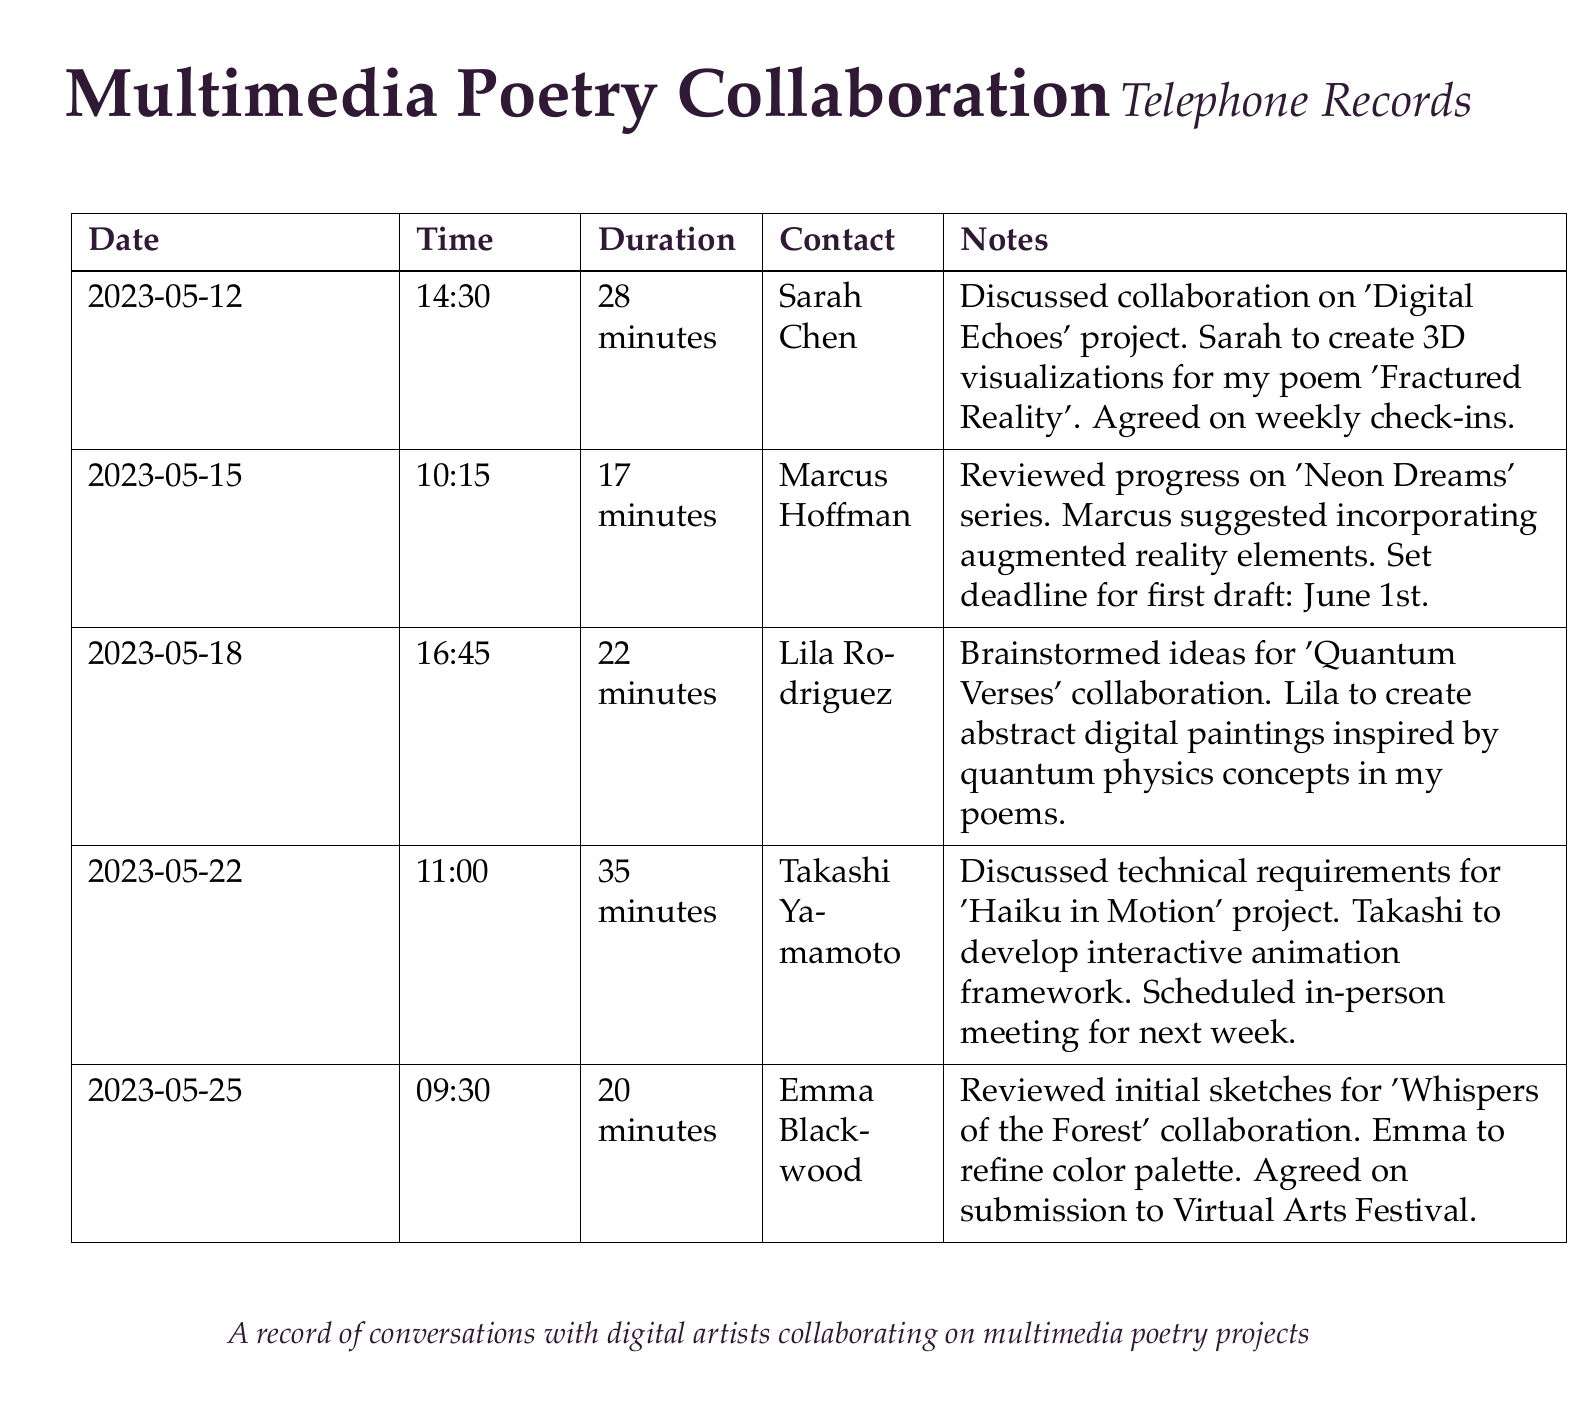What is the date of the first recorded conversation? The first recorded conversation took place on May 12, 2023.
Answer: May 12, 2023 Who is the contact for the 'Digital Echoes' project? The contact for the 'Digital Echoes' project is Sarah Chen.
Answer: Sarah Chen What is the duration of the call with Marcus Hoffman? The duration of the call with Marcus Hoffman is 17 minutes.
Answer: 17 minutes What project involves Lila Rodriguez? Lila Rodriguez is involved in the 'Quantum Verses' collaboration.
Answer: Quantum Verses How many minutes was the conversation with Emma Blackwood? The conversation with Emma Blackwood lasted 20 minutes.
Answer: 20 minutes What deadline was set for the first draft of 'Neon Dreams'? The deadline set for the first draft of 'Neon Dreams' is June 1st.
Answer: June 1st Who is responsible for creating 3D visualizations in 'Digital Echoes'? Sarah Chen is responsible for creating 3D visualizations in 'Digital Echoes'.
Answer: Sarah Chen What was the main focus of the call with Takashi Yamamoto? The main focus of the call with Takashi Yamamoto was discussing technical requirements.
Answer: Technical requirements How often will there be check-ins for the 'Digital Echoes' project? Weekly check-ins were agreed upon for the 'Digital Echoes' project.
Answer: Weekly What kind of art will Lila create for the collaboration? Lila will create abstract digital paintings for the collaboration.
Answer: Abstract digital paintings 